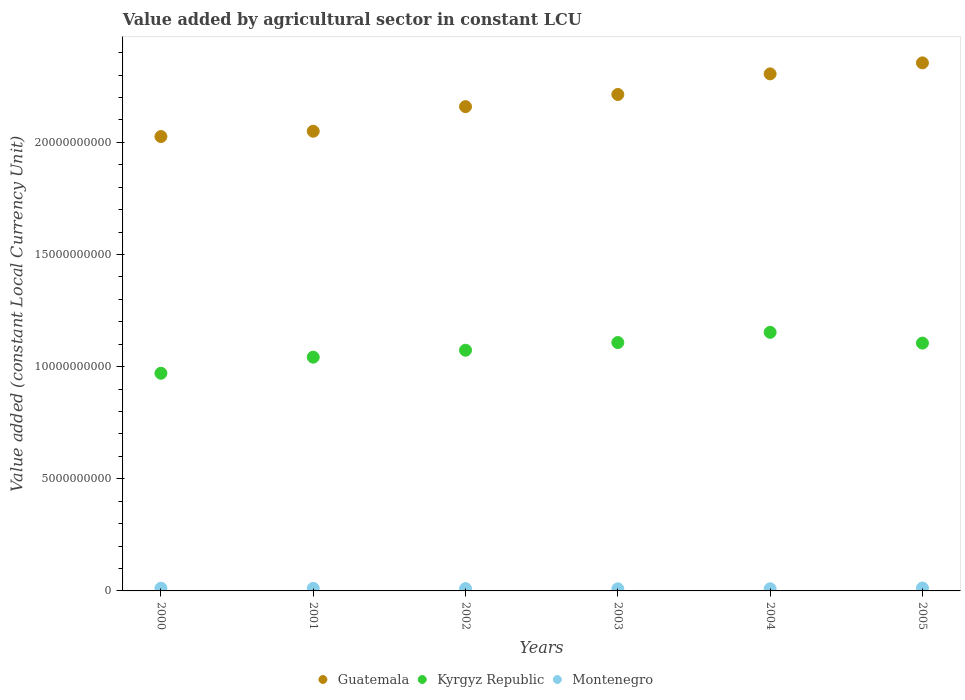What is the value added by agricultural sector in Kyrgyz Republic in 2003?
Keep it short and to the point. 1.11e+1. Across all years, what is the maximum value added by agricultural sector in Kyrgyz Republic?
Provide a succinct answer. 1.15e+1. Across all years, what is the minimum value added by agricultural sector in Kyrgyz Republic?
Your answer should be very brief. 9.71e+09. In which year was the value added by agricultural sector in Kyrgyz Republic minimum?
Give a very brief answer. 2000. What is the total value added by agricultural sector in Kyrgyz Republic in the graph?
Give a very brief answer. 6.45e+1. What is the difference between the value added by agricultural sector in Montenegro in 2002 and that in 2004?
Your response must be concise. 6.82e+06. What is the difference between the value added by agricultural sector in Montenegro in 2002 and the value added by agricultural sector in Kyrgyz Republic in 2005?
Provide a short and direct response. -1.09e+1. What is the average value added by agricultural sector in Guatemala per year?
Your answer should be compact. 2.19e+1. In the year 2004, what is the difference between the value added by agricultural sector in Kyrgyz Republic and value added by agricultural sector in Montenegro?
Offer a terse response. 1.14e+1. In how many years, is the value added by agricultural sector in Guatemala greater than 13000000000 LCU?
Ensure brevity in your answer.  6. What is the ratio of the value added by agricultural sector in Kyrgyz Republic in 2003 to that in 2004?
Provide a succinct answer. 0.96. What is the difference between the highest and the second highest value added by agricultural sector in Guatemala?
Your answer should be compact. 4.90e+08. What is the difference between the highest and the lowest value added by agricultural sector in Guatemala?
Your answer should be very brief. 3.29e+09. In how many years, is the value added by agricultural sector in Guatemala greater than the average value added by agricultural sector in Guatemala taken over all years?
Ensure brevity in your answer.  3. Is the sum of the value added by agricultural sector in Guatemala in 2002 and 2003 greater than the maximum value added by agricultural sector in Montenegro across all years?
Keep it short and to the point. Yes. Is it the case that in every year, the sum of the value added by agricultural sector in Guatemala and value added by agricultural sector in Montenegro  is greater than the value added by agricultural sector in Kyrgyz Republic?
Offer a terse response. Yes. How many dotlines are there?
Provide a succinct answer. 3. Where does the legend appear in the graph?
Your response must be concise. Bottom center. How are the legend labels stacked?
Give a very brief answer. Horizontal. What is the title of the graph?
Provide a short and direct response. Value added by agricultural sector in constant LCU. What is the label or title of the X-axis?
Keep it short and to the point. Years. What is the label or title of the Y-axis?
Make the answer very short. Value added (constant Local Currency Unit). What is the Value added (constant Local Currency Unit) in Guatemala in 2000?
Keep it short and to the point. 2.03e+1. What is the Value added (constant Local Currency Unit) of Kyrgyz Republic in 2000?
Ensure brevity in your answer.  9.71e+09. What is the Value added (constant Local Currency Unit) in Montenegro in 2000?
Give a very brief answer. 1.20e+08. What is the Value added (constant Local Currency Unit) in Guatemala in 2001?
Make the answer very short. 2.05e+1. What is the Value added (constant Local Currency Unit) of Kyrgyz Republic in 2001?
Give a very brief answer. 1.04e+1. What is the Value added (constant Local Currency Unit) in Montenegro in 2001?
Your response must be concise. 1.14e+08. What is the Value added (constant Local Currency Unit) in Guatemala in 2002?
Your answer should be very brief. 2.16e+1. What is the Value added (constant Local Currency Unit) in Kyrgyz Republic in 2002?
Your answer should be compact. 1.07e+1. What is the Value added (constant Local Currency Unit) in Montenegro in 2002?
Offer a very short reply. 1.03e+08. What is the Value added (constant Local Currency Unit) in Guatemala in 2003?
Give a very brief answer. 2.21e+1. What is the Value added (constant Local Currency Unit) of Kyrgyz Republic in 2003?
Give a very brief answer. 1.11e+1. What is the Value added (constant Local Currency Unit) of Montenegro in 2003?
Provide a short and direct response. 9.61e+07. What is the Value added (constant Local Currency Unit) in Guatemala in 2004?
Make the answer very short. 2.31e+1. What is the Value added (constant Local Currency Unit) of Kyrgyz Republic in 2004?
Provide a succinct answer. 1.15e+1. What is the Value added (constant Local Currency Unit) of Montenegro in 2004?
Offer a terse response. 9.60e+07. What is the Value added (constant Local Currency Unit) in Guatemala in 2005?
Provide a succinct answer. 2.35e+1. What is the Value added (constant Local Currency Unit) of Kyrgyz Republic in 2005?
Keep it short and to the point. 1.11e+1. What is the Value added (constant Local Currency Unit) of Montenegro in 2005?
Ensure brevity in your answer.  1.30e+08. Across all years, what is the maximum Value added (constant Local Currency Unit) in Guatemala?
Provide a short and direct response. 2.35e+1. Across all years, what is the maximum Value added (constant Local Currency Unit) in Kyrgyz Republic?
Your answer should be compact. 1.15e+1. Across all years, what is the maximum Value added (constant Local Currency Unit) in Montenegro?
Make the answer very short. 1.30e+08. Across all years, what is the minimum Value added (constant Local Currency Unit) of Guatemala?
Your answer should be very brief. 2.03e+1. Across all years, what is the minimum Value added (constant Local Currency Unit) of Kyrgyz Republic?
Offer a terse response. 9.71e+09. Across all years, what is the minimum Value added (constant Local Currency Unit) in Montenegro?
Offer a very short reply. 9.60e+07. What is the total Value added (constant Local Currency Unit) of Guatemala in the graph?
Provide a short and direct response. 1.31e+11. What is the total Value added (constant Local Currency Unit) in Kyrgyz Republic in the graph?
Keep it short and to the point. 6.45e+1. What is the total Value added (constant Local Currency Unit) in Montenegro in the graph?
Provide a succinct answer. 6.59e+08. What is the difference between the Value added (constant Local Currency Unit) of Guatemala in 2000 and that in 2001?
Offer a terse response. -2.36e+08. What is the difference between the Value added (constant Local Currency Unit) in Kyrgyz Republic in 2000 and that in 2001?
Keep it short and to the point. -7.18e+08. What is the difference between the Value added (constant Local Currency Unit) of Montenegro in 2000 and that in 2001?
Offer a terse response. 6.61e+06. What is the difference between the Value added (constant Local Currency Unit) of Guatemala in 2000 and that in 2002?
Your answer should be compact. -1.33e+09. What is the difference between the Value added (constant Local Currency Unit) in Kyrgyz Republic in 2000 and that in 2002?
Your answer should be very brief. -1.03e+09. What is the difference between the Value added (constant Local Currency Unit) in Montenegro in 2000 and that in 2002?
Keep it short and to the point. 1.76e+07. What is the difference between the Value added (constant Local Currency Unit) in Guatemala in 2000 and that in 2003?
Keep it short and to the point. -1.88e+09. What is the difference between the Value added (constant Local Currency Unit) of Kyrgyz Republic in 2000 and that in 2003?
Give a very brief answer. -1.37e+09. What is the difference between the Value added (constant Local Currency Unit) of Montenegro in 2000 and that in 2003?
Ensure brevity in your answer.  2.43e+07. What is the difference between the Value added (constant Local Currency Unit) of Guatemala in 2000 and that in 2004?
Keep it short and to the point. -2.79e+09. What is the difference between the Value added (constant Local Currency Unit) in Kyrgyz Republic in 2000 and that in 2004?
Offer a terse response. -1.83e+09. What is the difference between the Value added (constant Local Currency Unit) of Montenegro in 2000 and that in 2004?
Your response must be concise. 2.44e+07. What is the difference between the Value added (constant Local Currency Unit) in Guatemala in 2000 and that in 2005?
Provide a succinct answer. -3.29e+09. What is the difference between the Value added (constant Local Currency Unit) of Kyrgyz Republic in 2000 and that in 2005?
Provide a succinct answer. -1.35e+09. What is the difference between the Value added (constant Local Currency Unit) in Montenegro in 2000 and that in 2005?
Provide a short and direct response. -9.58e+06. What is the difference between the Value added (constant Local Currency Unit) of Guatemala in 2001 and that in 2002?
Make the answer very short. -1.10e+09. What is the difference between the Value added (constant Local Currency Unit) of Kyrgyz Republic in 2001 and that in 2002?
Offer a very short reply. -3.09e+08. What is the difference between the Value added (constant Local Currency Unit) in Montenegro in 2001 and that in 2002?
Your answer should be very brief. 1.10e+07. What is the difference between the Value added (constant Local Currency Unit) in Guatemala in 2001 and that in 2003?
Provide a short and direct response. -1.64e+09. What is the difference between the Value added (constant Local Currency Unit) in Kyrgyz Republic in 2001 and that in 2003?
Make the answer very short. -6.52e+08. What is the difference between the Value added (constant Local Currency Unit) of Montenegro in 2001 and that in 2003?
Provide a succinct answer. 1.77e+07. What is the difference between the Value added (constant Local Currency Unit) in Guatemala in 2001 and that in 2004?
Give a very brief answer. -2.56e+09. What is the difference between the Value added (constant Local Currency Unit) in Kyrgyz Republic in 2001 and that in 2004?
Offer a very short reply. -1.11e+09. What is the difference between the Value added (constant Local Currency Unit) in Montenegro in 2001 and that in 2004?
Offer a terse response. 1.78e+07. What is the difference between the Value added (constant Local Currency Unit) in Guatemala in 2001 and that in 2005?
Provide a succinct answer. -3.05e+09. What is the difference between the Value added (constant Local Currency Unit) of Kyrgyz Republic in 2001 and that in 2005?
Provide a short and direct response. -6.27e+08. What is the difference between the Value added (constant Local Currency Unit) of Montenegro in 2001 and that in 2005?
Your answer should be very brief. -1.62e+07. What is the difference between the Value added (constant Local Currency Unit) of Guatemala in 2002 and that in 2003?
Keep it short and to the point. -5.42e+08. What is the difference between the Value added (constant Local Currency Unit) in Kyrgyz Republic in 2002 and that in 2003?
Your answer should be very brief. -3.43e+08. What is the difference between the Value added (constant Local Currency Unit) in Montenegro in 2002 and that in 2003?
Offer a very short reply. 6.72e+06. What is the difference between the Value added (constant Local Currency Unit) in Guatemala in 2002 and that in 2004?
Provide a short and direct response. -1.46e+09. What is the difference between the Value added (constant Local Currency Unit) of Kyrgyz Republic in 2002 and that in 2004?
Your response must be concise. -7.98e+08. What is the difference between the Value added (constant Local Currency Unit) in Montenegro in 2002 and that in 2004?
Offer a terse response. 6.82e+06. What is the difference between the Value added (constant Local Currency Unit) of Guatemala in 2002 and that in 2005?
Make the answer very short. -1.95e+09. What is the difference between the Value added (constant Local Currency Unit) in Kyrgyz Republic in 2002 and that in 2005?
Offer a terse response. -3.18e+08. What is the difference between the Value added (constant Local Currency Unit) of Montenegro in 2002 and that in 2005?
Your response must be concise. -2.72e+07. What is the difference between the Value added (constant Local Currency Unit) of Guatemala in 2003 and that in 2004?
Make the answer very short. -9.19e+08. What is the difference between the Value added (constant Local Currency Unit) of Kyrgyz Republic in 2003 and that in 2004?
Keep it short and to the point. -4.55e+08. What is the difference between the Value added (constant Local Currency Unit) in Montenegro in 2003 and that in 2004?
Your answer should be compact. 1.03e+05. What is the difference between the Value added (constant Local Currency Unit) of Guatemala in 2003 and that in 2005?
Your response must be concise. -1.41e+09. What is the difference between the Value added (constant Local Currency Unit) of Kyrgyz Republic in 2003 and that in 2005?
Provide a short and direct response. 2.50e+07. What is the difference between the Value added (constant Local Currency Unit) of Montenegro in 2003 and that in 2005?
Provide a short and direct response. -3.39e+07. What is the difference between the Value added (constant Local Currency Unit) of Guatemala in 2004 and that in 2005?
Provide a short and direct response. -4.90e+08. What is the difference between the Value added (constant Local Currency Unit) of Kyrgyz Republic in 2004 and that in 2005?
Keep it short and to the point. 4.80e+08. What is the difference between the Value added (constant Local Currency Unit) of Montenegro in 2004 and that in 2005?
Provide a short and direct response. -3.40e+07. What is the difference between the Value added (constant Local Currency Unit) of Guatemala in 2000 and the Value added (constant Local Currency Unit) of Kyrgyz Republic in 2001?
Ensure brevity in your answer.  9.84e+09. What is the difference between the Value added (constant Local Currency Unit) of Guatemala in 2000 and the Value added (constant Local Currency Unit) of Montenegro in 2001?
Provide a succinct answer. 2.01e+1. What is the difference between the Value added (constant Local Currency Unit) in Kyrgyz Republic in 2000 and the Value added (constant Local Currency Unit) in Montenegro in 2001?
Your answer should be compact. 9.59e+09. What is the difference between the Value added (constant Local Currency Unit) of Guatemala in 2000 and the Value added (constant Local Currency Unit) of Kyrgyz Republic in 2002?
Offer a terse response. 9.53e+09. What is the difference between the Value added (constant Local Currency Unit) in Guatemala in 2000 and the Value added (constant Local Currency Unit) in Montenegro in 2002?
Keep it short and to the point. 2.02e+1. What is the difference between the Value added (constant Local Currency Unit) of Kyrgyz Republic in 2000 and the Value added (constant Local Currency Unit) of Montenegro in 2002?
Provide a short and direct response. 9.60e+09. What is the difference between the Value added (constant Local Currency Unit) of Guatemala in 2000 and the Value added (constant Local Currency Unit) of Kyrgyz Republic in 2003?
Offer a terse response. 9.19e+09. What is the difference between the Value added (constant Local Currency Unit) of Guatemala in 2000 and the Value added (constant Local Currency Unit) of Montenegro in 2003?
Your answer should be very brief. 2.02e+1. What is the difference between the Value added (constant Local Currency Unit) in Kyrgyz Republic in 2000 and the Value added (constant Local Currency Unit) in Montenegro in 2003?
Your response must be concise. 9.61e+09. What is the difference between the Value added (constant Local Currency Unit) in Guatemala in 2000 and the Value added (constant Local Currency Unit) in Kyrgyz Republic in 2004?
Give a very brief answer. 8.73e+09. What is the difference between the Value added (constant Local Currency Unit) in Guatemala in 2000 and the Value added (constant Local Currency Unit) in Montenegro in 2004?
Offer a very short reply. 2.02e+1. What is the difference between the Value added (constant Local Currency Unit) in Kyrgyz Republic in 2000 and the Value added (constant Local Currency Unit) in Montenegro in 2004?
Your response must be concise. 9.61e+09. What is the difference between the Value added (constant Local Currency Unit) in Guatemala in 2000 and the Value added (constant Local Currency Unit) in Kyrgyz Republic in 2005?
Offer a terse response. 9.21e+09. What is the difference between the Value added (constant Local Currency Unit) in Guatemala in 2000 and the Value added (constant Local Currency Unit) in Montenegro in 2005?
Keep it short and to the point. 2.01e+1. What is the difference between the Value added (constant Local Currency Unit) of Kyrgyz Republic in 2000 and the Value added (constant Local Currency Unit) of Montenegro in 2005?
Make the answer very short. 9.58e+09. What is the difference between the Value added (constant Local Currency Unit) of Guatemala in 2001 and the Value added (constant Local Currency Unit) of Kyrgyz Republic in 2002?
Provide a succinct answer. 9.77e+09. What is the difference between the Value added (constant Local Currency Unit) of Guatemala in 2001 and the Value added (constant Local Currency Unit) of Montenegro in 2002?
Make the answer very short. 2.04e+1. What is the difference between the Value added (constant Local Currency Unit) of Kyrgyz Republic in 2001 and the Value added (constant Local Currency Unit) of Montenegro in 2002?
Your answer should be compact. 1.03e+1. What is the difference between the Value added (constant Local Currency Unit) in Guatemala in 2001 and the Value added (constant Local Currency Unit) in Kyrgyz Republic in 2003?
Provide a short and direct response. 9.42e+09. What is the difference between the Value added (constant Local Currency Unit) of Guatemala in 2001 and the Value added (constant Local Currency Unit) of Montenegro in 2003?
Provide a short and direct response. 2.04e+1. What is the difference between the Value added (constant Local Currency Unit) in Kyrgyz Republic in 2001 and the Value added (constant Local Currency Unit) in Montenegro in 2003?
Provide a succinct answer. 1.03e+1. What is the difference between the Value added (constant Local Currency Unit) of Guatemala in 2001 and the Value added (constant Local Currency Unit) of Kyrgyz Republic in 2004?
Your response must be concise. 8.97e+09. What is the difference between the Value added (constant Local Currency Unit) in Guatemala in 2001 and the Value added (constant Local Currency Unit) in Montenegro in 2004?
Provide a short and direct response. 2.04e+1. What is the difference between the Value added (constant Local Currency Unit) of Kyrgyz Republic in 2001 and the Value added (constant Local Currency Unit) of Montenegro in 2004?
Your answer should be compact. 1.03e+1. What is the difference between the Value added (constant Local Currency Unit) of Guatemala in 2001 and the Value added (constant Local Currency Unit) of Kyrgyz Republic in 2005?
Keep it short and to the point. 9.45e+09. What is the difference between the Value added (constant Local Currency Unit) in Guatemala in 2001 and the Value added (constant Local Currency Unit) in Montenegro in 2005?
Offer a very short reply. 2.04e+1. What is the difference between the Value added (constant Local Currency Unit) of Kyrgyz Republic in 2001 and the Value added (constant Local Currency Unit) of Montenegro in 2005?
Make the answer very short. 1.03e+1. What is the difference between the Value added (constant Local Currency Unit) in Guatemala in 2002 and the Value added (constant Local Currency Unit) in Kyrgyz Republic in 2003?
Provide a short and direct response. 1.05e+1. What is the difference between the Value added (constant Local Currency Unit) of Guatemala in 2002 and the Value added (constant Local Currency Unit) of Montenegro in 2003?
Your answer should be very brief. 2.15e+1. What is the difference between the Value added (constant Local Currency Unit) in Kyrgyz Republic in 2002 and the Value added (constant Local Currency Unit) in Montenegro in 2003?
Your response must be concise. 1.06e+1. What is the difference between the Value added (constant Local Currency Unit) of Guatemala in 2002 and the Value added (constant Local Currency Unit) of Kyrgyz Republic in 2004?
Ensure brevity in your answer.  1.01e+1. What is the difference between the Value added (constant Local Currency Unit) of Guatemala in 2002 and the Value added (constant Local Currency Unit) of Montenegro in 2004?
Offer a terse response. 2.15e+1. What is the difference between the Value added (constant Local Currency Unit) in Kyrgyz Republic in 2002 and the Value added (constant Local Currency Unit) in Montenegro in 2004?
Make the answer very short. 1.06e+1. What is the difference between the Value added (constant Local Currency Unit) in Guatemala in 2002 and the Value added (constant Local Currency Unit) in Kyrgyz Republic in 2005?
Your answer should be very brief. 1.05e+1. What is the difference between the Value added (constant Local Currency Unit) of Guatemala in 2002 and the Value added (constant Local Currency Unit) of Montenegro in 2005?
Provide a short and direct response. 2.15e+1. What is the difference between the Value added (constant Local Currency Unit) of Kyrgyz Republic in 2002 and the Value added (constant Local Currency Unit) of Montenegro in 2005?
Your answer should be very brief. 1.06e+1. What is the difference between the Value added (constant Local Currency Unit) of Guatemala in 2003 and the Value added (constant Local Currency Unit) of Kyrgyz Republic in 2004?
Give a very brief answer. 1.06e+1. What is the difference between the Value added (constant Local Currency Unit) of Guatemala in 2003 and the Value added (constant Local Currency Unit) of Montenegro in 2004?
Give a very brief answer. 2.20e+1. What is the difference between the Value added (constant Local Currency Unit) in Kyrgyz Republic in 2003 and the Value added (constant Local Currency Unit) in Montenegro in 2004?
Keep it short and to the point. 1.10e+1. What is the difference between the Value added (constant Local Currency Unit) in Guatemala in 2003 and the Value added (constant Local Currency Unit) in Kyrgyz Republic in 2005?
Ensure brevity in your answer.  1.11e+1. What is the difference between the Value added (constant Local Currency Unit) in Guatemala in 2003 and the Value added (constant Local Currency Unit) in Montenegro in 2005?
Make the answer very short. 2.20e+1. What is the difference between the Value added (constant Local Currency Unit) of Kyrgyz Republic in 2003 and the Value added (constant Local Currency Unit) of Montenegro in 2005?
Your answer should be compact. 1.09e+1. What is the difference between the Value added (constant Local Currency Unit) of Guatemala in 2004 and the Value added (constant Local Currency Unit) of Kyrgyz Republic in 2005?
Your response must be concise. 1.20e+1. What is the difference between the Value added (constant Local Currency Unit) in Guatemala in 2004 and the Value added (constant Local Currency Unit) in Montenegro in 2005?
Offer a very short reply. 2.29e+1. What is the difference between the Value added (constant Local Currency Unit) in Kyrgyz Republic in 2004 and the Value added (constant Local Currency Unit) in Montenegro in 2005?
Keep it short and to the point. 1.14e+1. What is the average Value added (constant Local Currency Unit) in Guatemala per year?
Ensure brevity in your answer.  2.19e+1. What is the average Value added (constant Local Currency Unit) in Kyrgyz Republic per year?
Ensure brevity in your answer.  1.08e+1. What is the average Value added (constant Local Currency Unit) in Montenegro per year?
Keep it short and to the point. 1.10e+08. In the year 2000, what is the difference between the Value added (constant Local Currency Unit) of Guatemala and Value added (constant Local Currency Unit) of Kyrgyz Republic?
Provide a short and direct response. 1.06e+1. In the year 2000, what is the difference between the Value added (constant Local Currency Unit) of Guatemala and Value added (constant Local Currency Unit) of Montenegro?
Keep it short and to the point. 2.01e+1. In the year 2000, what is the difference between the Value added (constant Local Currency Unit) of Kyrgyz Republic and Value added (constant Local Currency Unit) of Montenegro?
Offer a very short reply. 9.59e+09. In the year 2001, what is the difference between the Value added (constant Local Currency Unit) of Guatemala and Value added (constant Local Currency Unit) of Kyrgyz Republic?
Ensure brevity in your answer.  1.01e+1. In the year 2001, what is the difference between the Value added (constant Local Currency Unit) in Guatemala and Value added (constant Local Currency Unit) in Montenegro?
Make the answer very short. 2.04e+1. In the year 2001, what is the difference between the Value added (constant Local Currency Unit) of Kyrgyz Republic and Value added (constant Local Currency Unit) of Montenegro?
Your response must be concise. 1.03e+1. In the year 2002, what is the difference between the Value added (constant Local Currency Unit) in Guatemala and Value added (constant Local Currency Unit) in Kyrgyz Republic?
Your response must be concise. 1.09e+1. In the year 2002, what is the difference between the Value added (constant Local Currency Unit) in Guatemala and Value added (constant Local Currency Unit) in Montenegro?
Give a very brief answer. 2.15e+1. In the year 2002, what is the difference between the Value added (constant Local Currency Unit) of Kyrgyz Republic and Value added (constant Local Currency Unit) of Montenegro?
Give a very brief answer. 1.06e+1. In the year 2003, what is the difference between the Value added (constant Local Currency Unit) in Guatemala and Value added (constant Local Currency Unit) in Kyrgyz Republic?
Offer a very short reply. 1.11e+1. In the year 2003, what is the difference between the Value added (constant Local Currency Unit) of Guatemala and Value added (constant Local Currency Unit) of Montenegro?
Provide a short and direct response. 2.20e+1. In the year 2003, what is the difference between the Value added (constant Local Currency Unit) of Kyrgyz Republic and Value added (constant Local Currency Unit) of Montenegro?
Provide a succinct answer. 1.10e+1. In the year 2004, what is the difference between the Value added (constant Local Currency Unit) in Guatemala and Value added (constant Local Currency Unit) in Kyrgyz Republic?
Your answer should be compact. 1.15e+1. In the year 2004, what is the difference between the Value added (constant Local Currency Unit) of Guatemala and Value added (constant Local Currency Unit) of Montenegro?
Your response must be concise. 2.30e+1. In the year 2004, what is the difference between the Value added (constant Local Currency Unit) in Kyrgyz Republic and Value added (constant Local Currency Unit) in Montenegro?
Keep it short and to the point. 1.14e+1. In the year 2005, what is the difference between the Value added (constant Local Currency Unit) in Guatemala and Value added (constant Local Currency Unit) in Kyrgyz Republic?
Your answer should be very brief. 1.25e+1. In the year 2005, what is the difference between the Value added (constant Local Currency Unit) of Guatemala and Value added (constant Local Currency Unit) of Montenegro?
Keep it short and to the point. 2.34e+1. In the year 2005, what is the difference between the Value added (constant Local Currency Unit) in Kyrgyz Republic and Value added (constant Local Currency Unit) in Montenegro?
Your response must be concise. 1.09e+1. What is the ratio of the Value added (constant Local Currency Unit) in Guatemala in 2000 to that in 2001?
Your response must be concise. 0.99. What is the ratio of the Value added (constant Local Currency Unit) of Kyrgyz Republic in 2000 to that in 2001?
Your response must be concise. 0.93. What is the ratio of the Value added (constant Local Currency Unit) in Montenegro in 2000 to that in 2001?
Your answer should be compact. 1.06. What is the ratio of the Value added (constant Local Currency Unit) of Guatemala in 2000 to that in 2002?
Give a very brief answer. 0.94. What is the ratio of the Value added (constant Local Currency Unit) of Kyrgyz Republic in 2000 to that in 2002?
Your answer should be very brief. 0.9. What is the ratio of the Value added (constant Local Currency Unit) in Montenegro in 2000 to that in 2002?
Keep it short and to the point. 1.17. What is the ratio of the Value added (constant Local Currency Unit) of Guatemala in 2000 to that in 2003?
Offer a very short reply. 0.92. What is the ratio of the Value added (constant Local Currency Unit) in Kyrgyz Republic in 2000 to that in 2003?
Your answer should be compact. 0.88. What is the ratio of the Value added (constant Local Currency Unit) in Montenegro in 2000 to that in 2003?
Your response must be concise. 1.25. What is the ratio of the Value added (constant Local Currency Unit) of Guatemala in 2000 to that in 2004?
Give a very brief answer. 0.88. What is the ratio of the Value added (constant Local Currency Unit) in Kyrgyz Republic in 2000 to that in 2004?
Give a very brief answer. 0.84. What is the ratio of the Value added (constant Local Currency Unit) of Montenegro in 2000 to that in 2004?
Offer a terse response. 1.25. What is the ratio of the Value added (constant Local Currency Unit) in Guatemala in 2000 to that in 2005?
Ensure brevity in your answer.  0.86. What is the ratio of the Value added (constant Local Currency Unit) of Kyrgyz Republic in 2000 to that in 2005?
Provide a succinct answer. 0.88. What is the ratio of the Value added (constant Local Currency Unit) in Montenegro in 2000 to that in 2005?
Your response must be concise. 0.93. What is the ratio of the Value added (constant Local Currency Unit) of Guatemala in 2001 to that in 2002?
Keep it short and to the point. 0.95. What is the ratio of the Value added (constant Local Currency Unit) in Kyrgyz Republic in 2001 to that in 2002?
Keep it short and to the point. 0.97. What is the ratio of the Value added (constant Local Currency Unit) in Montenegro in 2001 to that in 2002?
Ensure brevity in your answer.  1.11. What is the ratio of the Value added (constant Local Currency Unit) of Guatemala in 2001 to that in 2003?
Offer a very short reply. 0.93. What is the ratio of the Value added (constant Local Currency Unit) in Kyrgyz Republic in 2001 to that in 2003?
Provide a short and direct response. 0.94. What is the ratio of the Value added (constant Local Currency Unit) of Montenegro in 2001 to that in 2003?
Keep it short and to the point. 1.18. What is the ratio of the Value added (constant Local Currency Unit) in Guatemala in 2001 to that in 2004?
Your answer should be compact. 0.89. What is the ratio of the Value added (constant Local Currency Unit) in Kyrgyz Republic in 2001 to that in 2004?
Your answer should be very brief. 0.9. What is the ratio of the Value added (constant Local Currency Unit) of Montenegro in 2001 to that in 2004?
Ensure brevity in your answer.  1.19. What is the ratio of the Value added (constant Local Currency Unit) of Guatemala in 2001 to that in 2005?
Ensure brevity in your answer.  0.87. What is the ratio of the Value added (constant Local Currency Unit) in Kyrgyz Republic in 2001 to that in 2005?
Make the answer very short. 0.94. What is the ratio of the Value added (constant Local Currency Unit) of Montenegro in 2001 to that in 2005?
Keep it short and to the point. 0.88. What is the ratio of the Value added (constant Local Currency Unit) in Guatemala in 2002 to that in 2003?
Keep it short and to the point. 0.98. What is the ratio of the Value added (constant Local Currency Unit) in Montenegro in 2002 to that in 2003?
Your response must be concise. 1.07. What is the ratio of the Value added (constant Local Currency Unit) of Guatemala in 2002 to that in 2004?
Make the answer very short. 0.94. What is the ratio of the Value added (constant Local Currency Unit) in Kyrgyz Republic in 2002 to that in 2004?
Give a very brief answer. 0.93. What is the ratio of the Value added (constant Local Currency Unit) in Montenegro in 2002 to that in 2004?
Your answer should be very brief. 1.07. What is the ratio of the Value added (constant Local Currency Unit) in Guatemala in 2002 to that in 2005?
Ensure brevity in your answer.  0.92. What is the ratio of the Value added (constant Local Currency Unit) of Kyrgyz Republic in 2002 to that in 2005?
Make the answer very short. 0.97. What is the ratio of the Value added (constant Local Currency Unit) of Montenegro in 2002 to that in 2005?
Keep it short and to the point. 0.79. What is the ratio of the Value added (constant Local Currency Unit) of Guatemala in 2003 to that in 2004?
Offer a terse response. 0.96. What is the ratio of the Value added (constant Local Currency Unit) of Kyrgyz Republic in 2003 to that in 2004?
Offer a very short reply. 0.96. What is the ratio of the Value added (constant Local Currency Unit) in Montenegro in 2003 to that in 2004?
Your response must be concise. 1. What is the ratio of the Value added (constant Local Currency Unit) in Guatemala in 2003 to that in 2005?
Give a very brief answer. 0.94. What is the ratio of the Value added (constant Local Currency Unit) of Montenegro in 2003 to that in 2005?
Give a very brief answer. 0.74. What is the ratio of the Value added (constant Local Currency Unit) of Guatemala in 2004 to that in 2005?
Your answer should be compact. 0.98. What is the ratio of the Value added (constant Local Currency Unit) in Kyrgyz Republic in 2004 to that in 2005?
Offer a terse response. 1.04. What is the ratio of the Value added (constant Local Currency Unit) of Montenegro in 2004 to that in 2005?
Provide a succinct answer. 0.74. What is the difference between the highest and the second highest Value added (constant Local Currency Unit) of Guatemala?
Provide a succinct answer. 4.90e+08. What is the difference between the highest and the second highest Value added (constant Local Currency Unit) in Kyrgyz Republic?
Offer a very short reply. 4.55e+08. What is the difference between the highest and the second highest Value added (constant Local Currency Unit) of Montenegro?
Provide a short and direct response. 9.58e+06. What is the difference between the highest and the lowest Value added (constant Local Currency Unit) in Guatemala?
Provide a short and direct response. 3.29e+09. What is the difference between the highest and the lowest Value added (constant Local Currency Unit) in Kyrgyz Republic?
Keep it short and to the point. 1.83e+09. What is the difference between the highest and the lowest Value added (constant Local Currency Unit) of Montenegro?
Provide a succinct answer. 3.40e+07. 